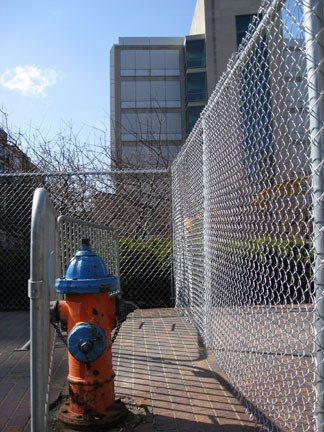Describe the objects in this image and their specific colors. I can see a fire hydrant in lightblue, black, maroon, navy, and gray tones in this image. 